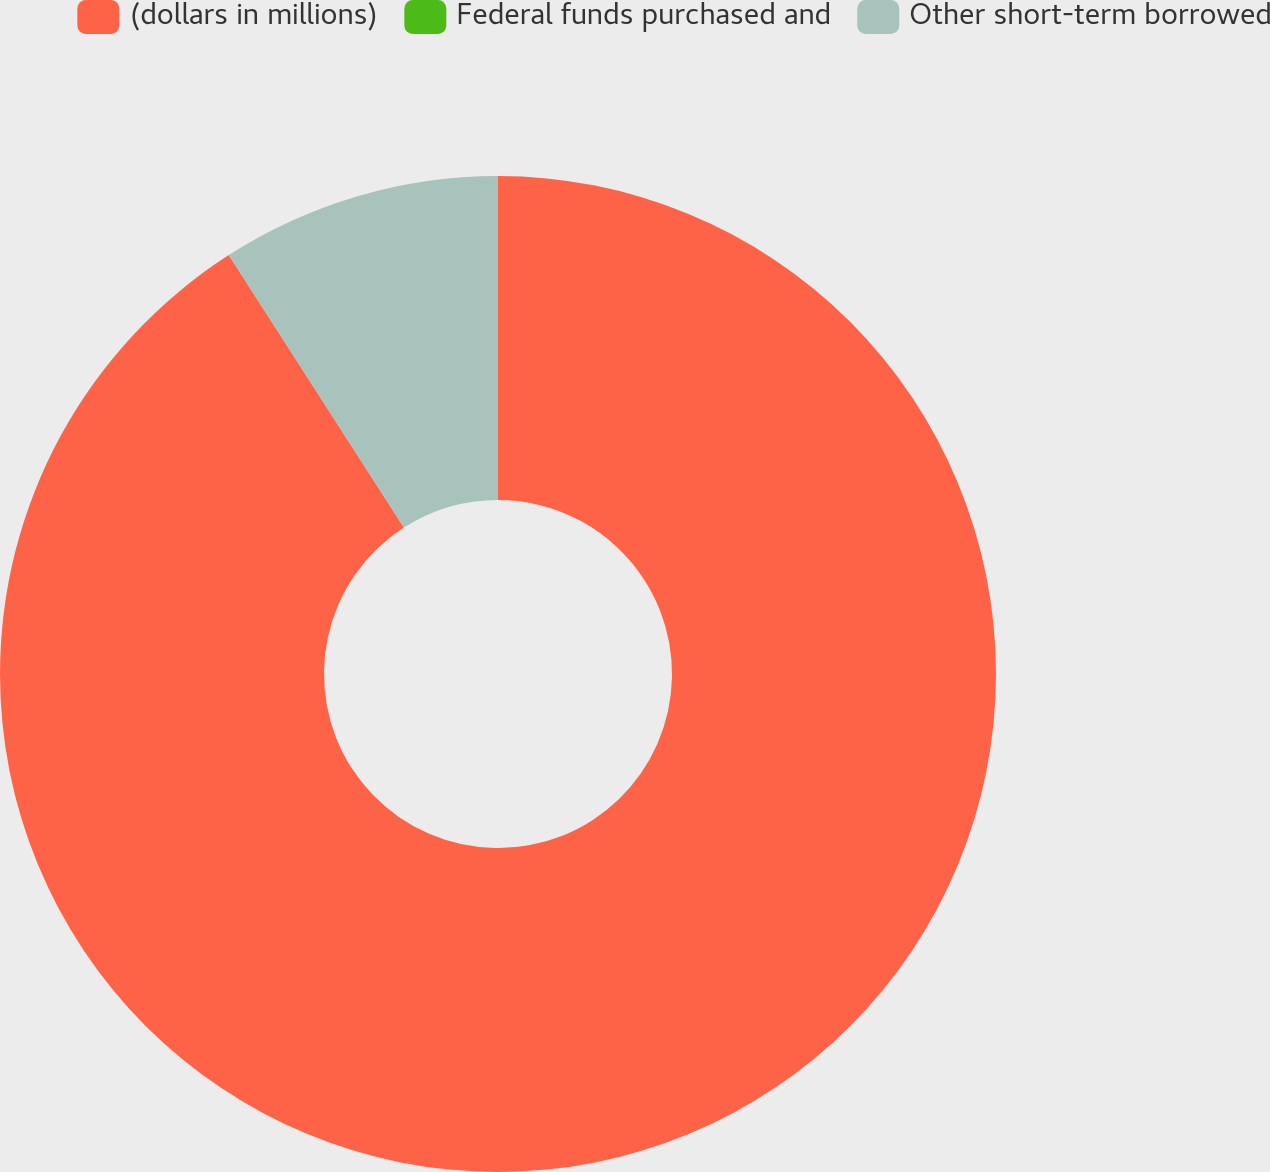Convert chart. <chart><loc_0><loc_0><loc_500><loc_500><pie_chart><fcel>(dollars in millions)<fcel>Federal funds purchased and<fcel>Other short-term borrowed<nl><fcel>90.9%<fcel>0.0%<fcel>9.09%<nl></chart> 